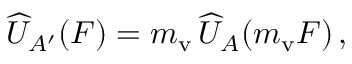Convert formula to latex. <formula><loc_0><loc_0><loc_500><loc_500>\widehat { U } _ { A ^ { \prime } } ( \boldsymbol F ) = m _ { v } \, \widehat { U } _ { A } ( m _ { v } \boldsymbol F ) \, ,</formula> 